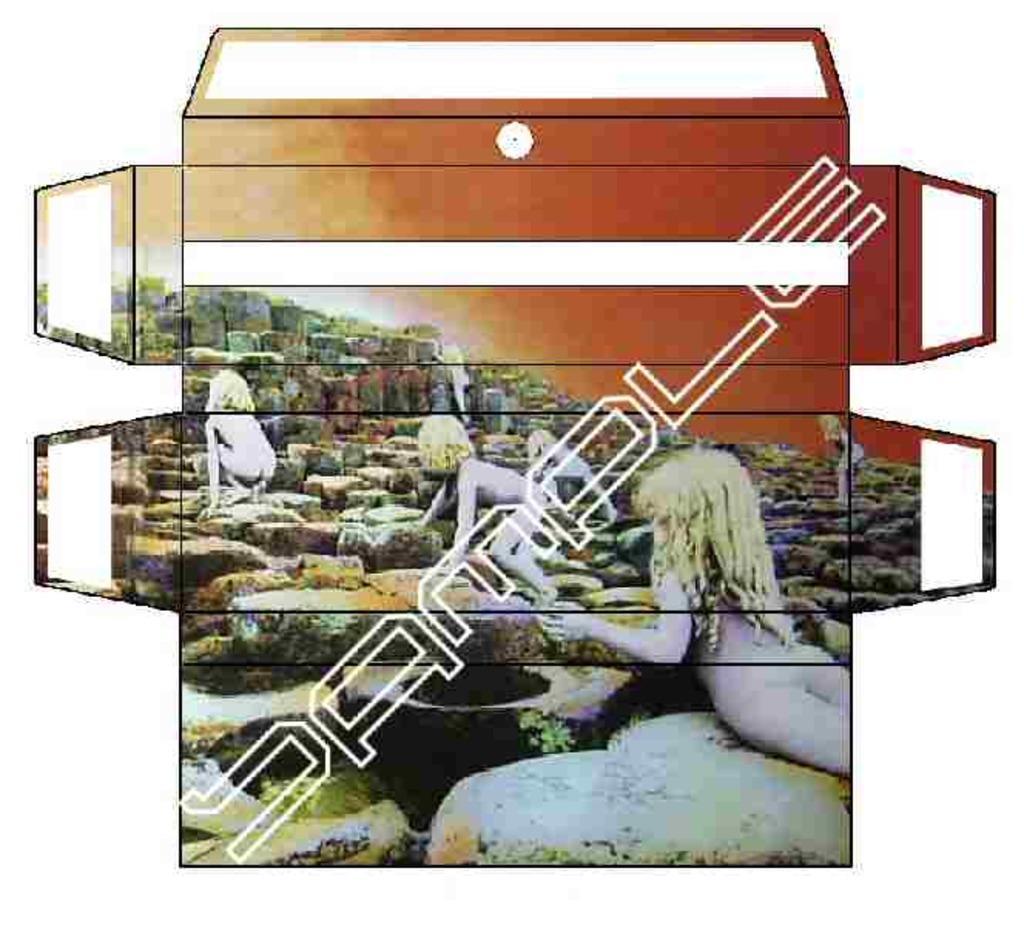How would you summarize this image in a sentence or two? In this image there are depictions of persons. 